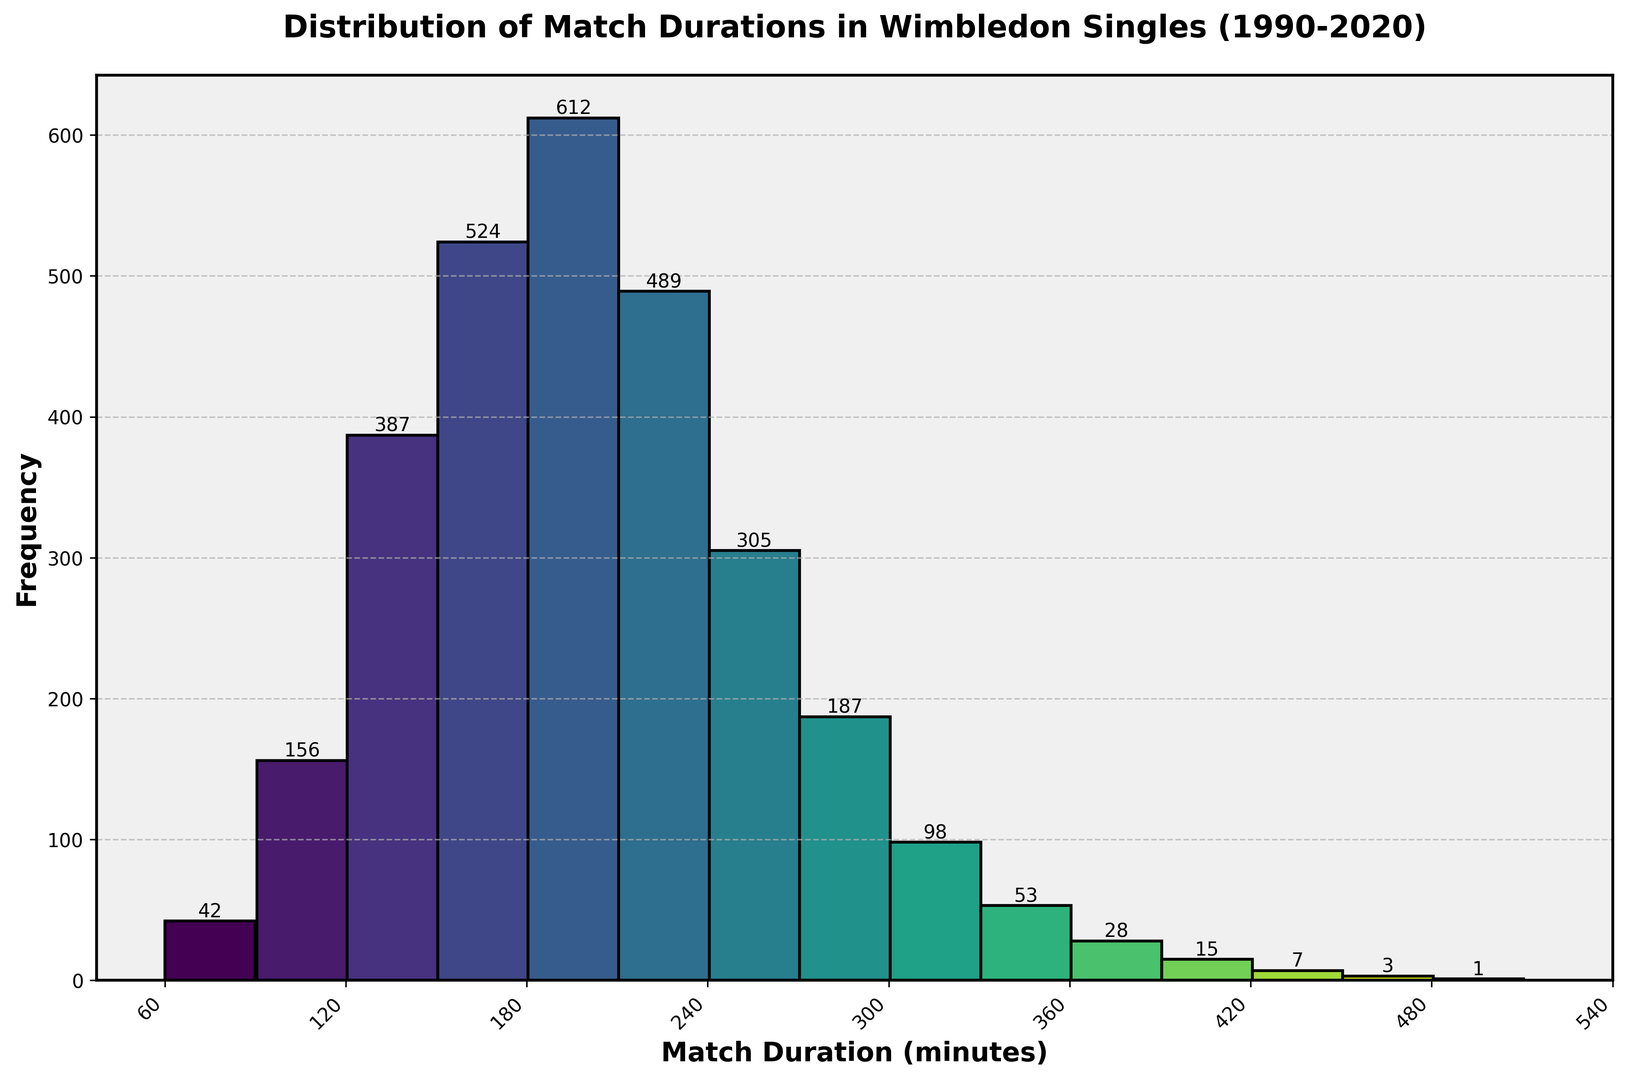What is the most frequent match duration range? The highest bar represents the most frequent match duration, which is between 181 and 210 minutes.
Answer: 181-210 minutes How many matches lasted between 241 and 300 minutes? To find the total number of matches in this range, add the frequencies for the 241-270 and 271-300 durations: 305 + 187 = 492.
Answer: 492 What is the duration range with the least number of matches? The shortest bar represents the least frequent range, which is between 481 and 510 minutes.
Answer: 481-510 minutes How many more matches lasted between 151 and 180 minutes compared to 91 and 120 minutes? The frequency for 151-180 minutes is 524, and for 91-120 minutes is 156. Subtract the latter from the former: 524 - 156 = 368.
Answer: 368 What is the total number of matches that lasted 301 minutes or longer? Sum the frequencies of all duration ranges from 301 minutes and above: 98 + 53 + 28 + 15 + 7 + 3 + 1 = 205.
Answer: 205 What is the difference in frequency between matches that lasted 211-240 minutes and those that lasted 421-450 minutes? The frequency for 211-240 minutes is 489 and for 421-450 minutes is 7. Subtract the latter from the former: 489 - 7 = 482.
Answer: 482 Which duration ranges have frequencies above 400 but below 600? By visually inspecting the bars, the ranges 151-180 minutes and 181-210 minutes have frequencies within this range (524 and 612 respectively, but only 524 counts). Therefore, the range is 151-180 minutes.
Answer: 151-180 minutes How does the frequency of matches lasting 91-120 minutes compare to those lasting 331-360 minutes? The frequency for 91-120 minutes is 156 and for 331-360 minutes is 53. Therefore, matches lasting 91-120 minutes are more frequent.
Answer: 91-120 minutes are more frequent How many matches lasted more than 360 minutes? Sum the frequencies for the duration ranges from 361 minutes and above: 28 + 15 + 7 + 3 + 1 = 54.
Answer: 54 Which color corresponds to the highest frequency range? The highest frequency bar is for 181-210 minutes. By looking at the color gradient used (from light to dark), the bar is in a darker green shade.
Answer: Dark green 